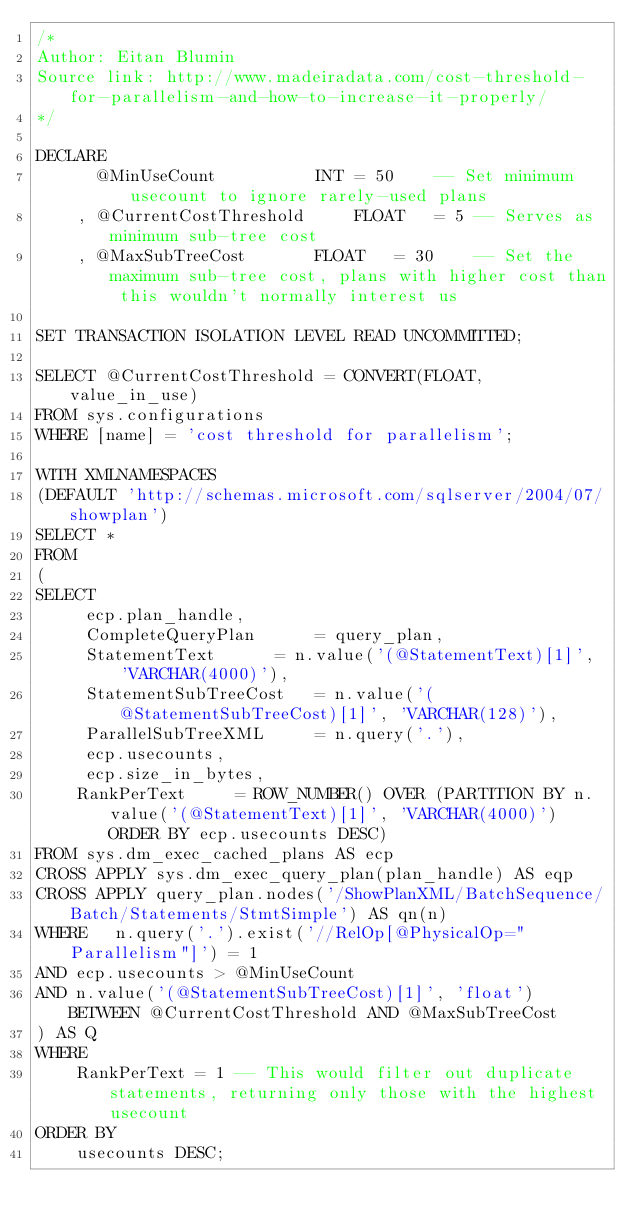<code> <loc_0><loc_0><loc_500><loc_500><_SQL_>/*
Author: Eitan Blumin
Source link: http://www.madeiradata.com/cost-threshold-for-parallelism-and-how-to-increase-it-properly/
*/

DECLARE
      @MinUseCount			INT	= 50	-- Set minimum usecount to ignore rarely-used plans
    , @CurrentCostThreshold		FLOAT	= 5	-- Serves as minimum sub-tree cost
    , @MaxSubTreeCost		FLOAT	= 30	-- Set the maximum sub-tree cost, plans with higher cost than this wouldn't normally interest us

SET TRANSACTION ISOLATION LEVEL READ UNCOMMITTED;

SELECT @CurrentCostThreshold = CONVERT(FLOAT, value_in_use)
FROM sys.configurations
WHERE [name] = 'cost threshold for parallelism';

WITH XMLNAMESPACES   
(DEFAULT 'http://schemas.microsoft.com/sqlserver/2004/07/showplan')
SELECT *
FROM
(
SELECT
     ecp.plan_handle,
     CompleteQueryPlan		= query_plan, 
     StatementText		= n.value('(@StatementText)[1]', 'VARCHAR(4000)'), 
     StatementSubTreeCost	= n.value('(@StatementSubTreeCost)[1]', 'VARCHAR(128)'), 
     ParallelSubTreeXML		= n.query('.'),  
     ecp.usecounts, 
     ecp.size_in_bytes,
    RankPerText		= ROW_NUMBER() OVER (PARTITION BY n.value('(@StatementText)[1]', 'VARCHAR(4000)') ORDER BY ecp.usecounts DESC)
FROM sys.dm_exec_cached_plans AS ecp 
CROSS APPLY sys.dm_exec_query_plan(plan_handle) AS eqp 
CROSS APPLY query_plan.nodes('/ShowPlanXML/BatchSequence/Batch/Statements/StmtSimple') AS qn(n)
WHERE	n.query('.').exist('//RelOp[@PhysicalOp="Parallelism"]') = 1 
AND	ecp.usecounts > @MinUseCount
AND	n.value('(@StatementSubTreeCost)[1]', 'float') BETWEEN @CurrentCostThreshold AND @MaxSubTreeCost
) AS Q
WHERE
    RankPerText = 1 -- This would filter out duplicate statements, returning only those with the highest usecount
ORDER BY
    usecounts DESC;
</code> 